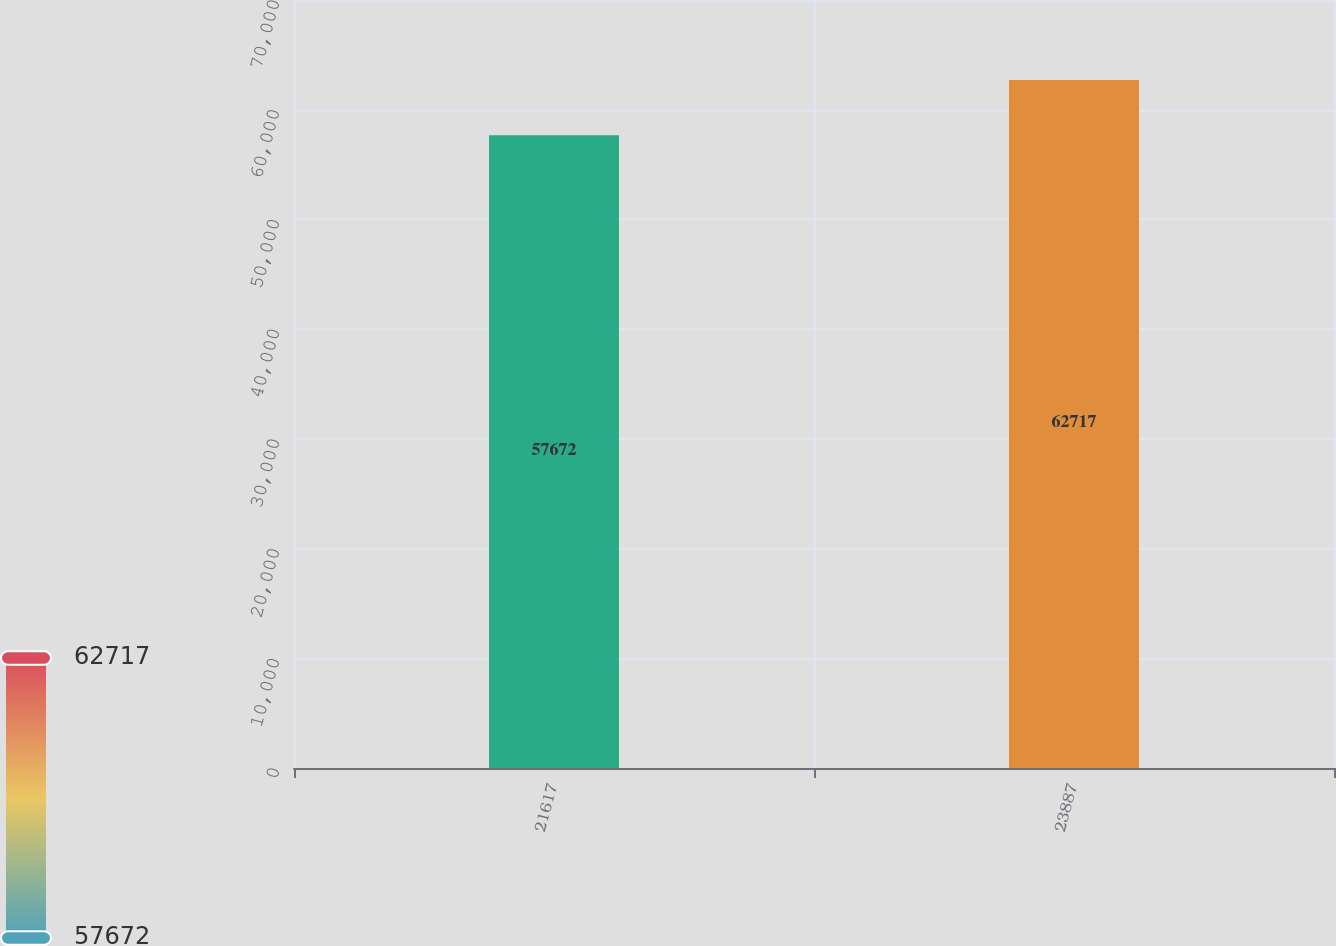Convert chart. <chart><loc_0><loc_0><loc_500><loc_500><bar_chart><fcel>21617<fcel>23887<nl><fcel>57672<fcel>62717<nl></chart> 